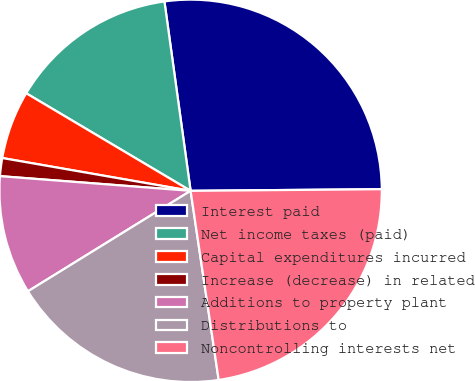Convert chart to OTSL. <chart><loc_0><loc_0><loc_500><loc_500><pie_chart><fcel>Interest paid<fcel>Net income taxes (paid)<fcel>Capital expenditures incurred<fcel>Increase (decrease) in related<fcel>Additions to property plant<fcel>Distributions to<fcel>Noncontrolling interests net<nl><fcel>27.05%<fcel>14.29%<fcel>5.78%<fcel>1.52%<fcel>10.03%<fcel>18.54%<fcel>22.79%<nl></chart> 